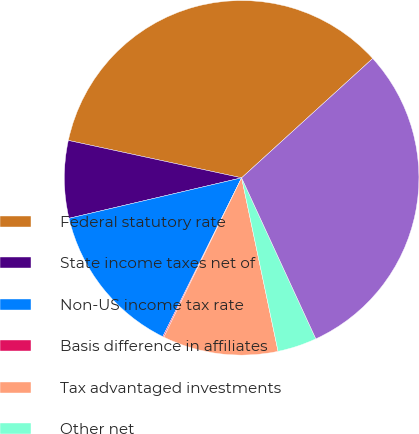Convert chart to OTSL. <chart><loc_0><loc_0><loc_500><loc_500><pie_chart><fcel>Federal statutory rate<fcel>State income taxes net of<fcel>Non-US income tax rate<fcel>Basis difference in affiliates<fcel>Tax advantaged investments<fcel>Other net<fcel>Effective income tax rate<nl><fcel>34.86%<fcel>7.05%<fcel>14.0%<fcel>0.1%<fcel>10.53%<fcel>3.58%<fcel>29.88%<nl></chart> 